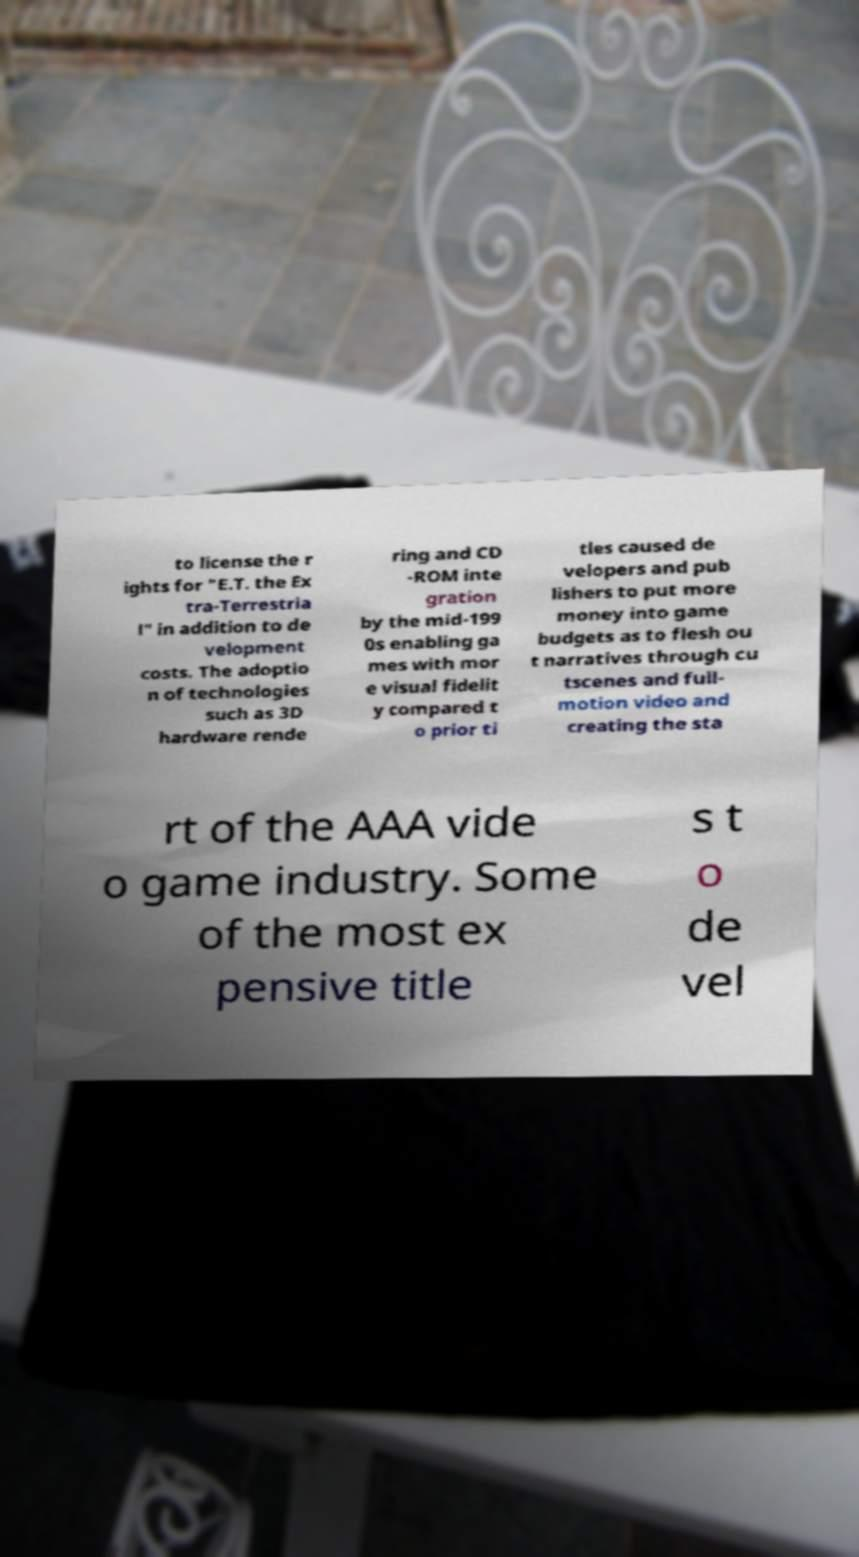Please read and relay the text visible in this image. What does it say? to license the r ights for "E.T. the Ex tra-Terrestria l" in addition to de velopment costs. The adoptio n of technologies such as 3D hardware rende ring and CD -ROM inte gration by the mid-199 0s enabling ga mes with mor e visual fidelit y compared t o prior ti tles caused de velopers and pub lishers to put more money into game budgets as to flesh ou t narratives through cu tscenes and full- motion video and creating the sta rt of the AAA vide o game industry. Some of the most ex pensive title s t o de vel 